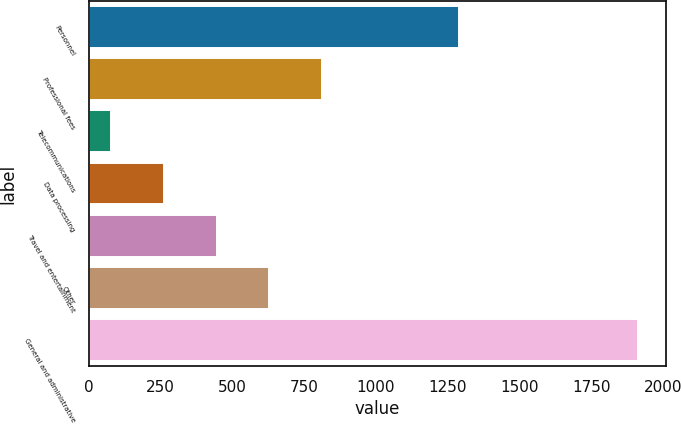Convert chart to OTSL. <chart><loc_0><loc_0><loc_500><loc_500><bar_chart><fcel>Personnel<fcel>Professional fees<fcel>Telecommunications<fcel>Data processing<fcel>Travel and entertainment<fcel>Other<fcel>General and administrative<nl><fcel>1290<fcel>812.4<fcel>78<fcel>261.6<fcel>445.2<fcel>628.8<fcel>1914<nl></chart> 